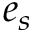Convert formula to latex. <formula><loc_0><loc_0><loc_500><loc_500>e _ { s }</formula> 